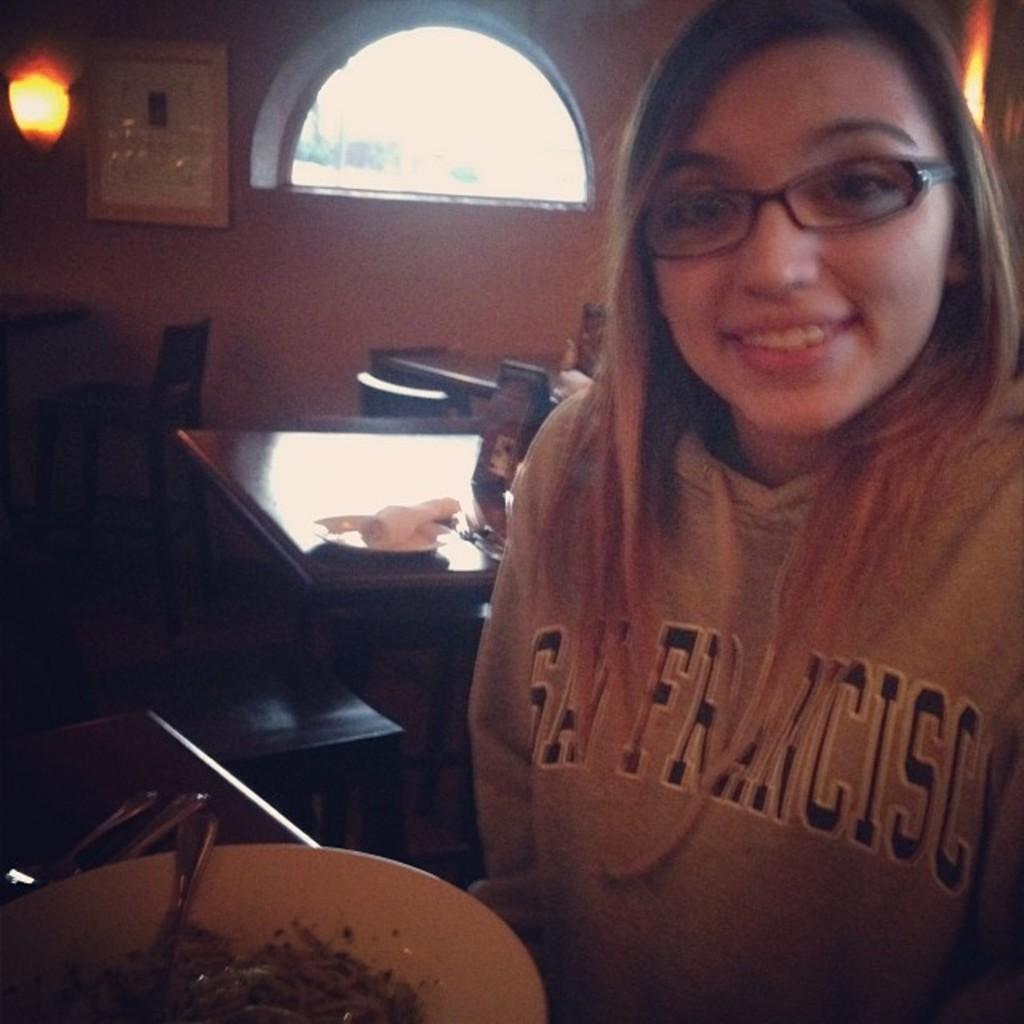Describe this image in one or two sentences. In this image there is a person holding a plate with spoon. There is food on the plate. There are tables and chairs. There is a wall. There is a window. 